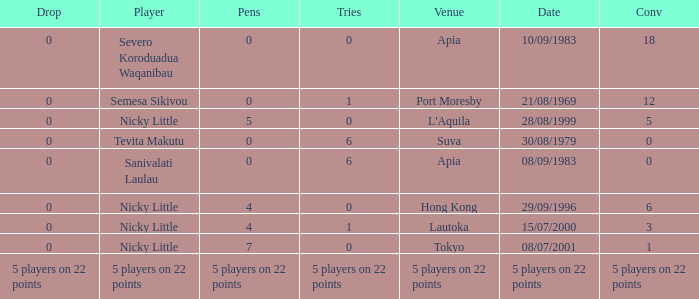How many conversions did Severo Koroduadua Waqanibau have when he has 0 pens? 18.0. 